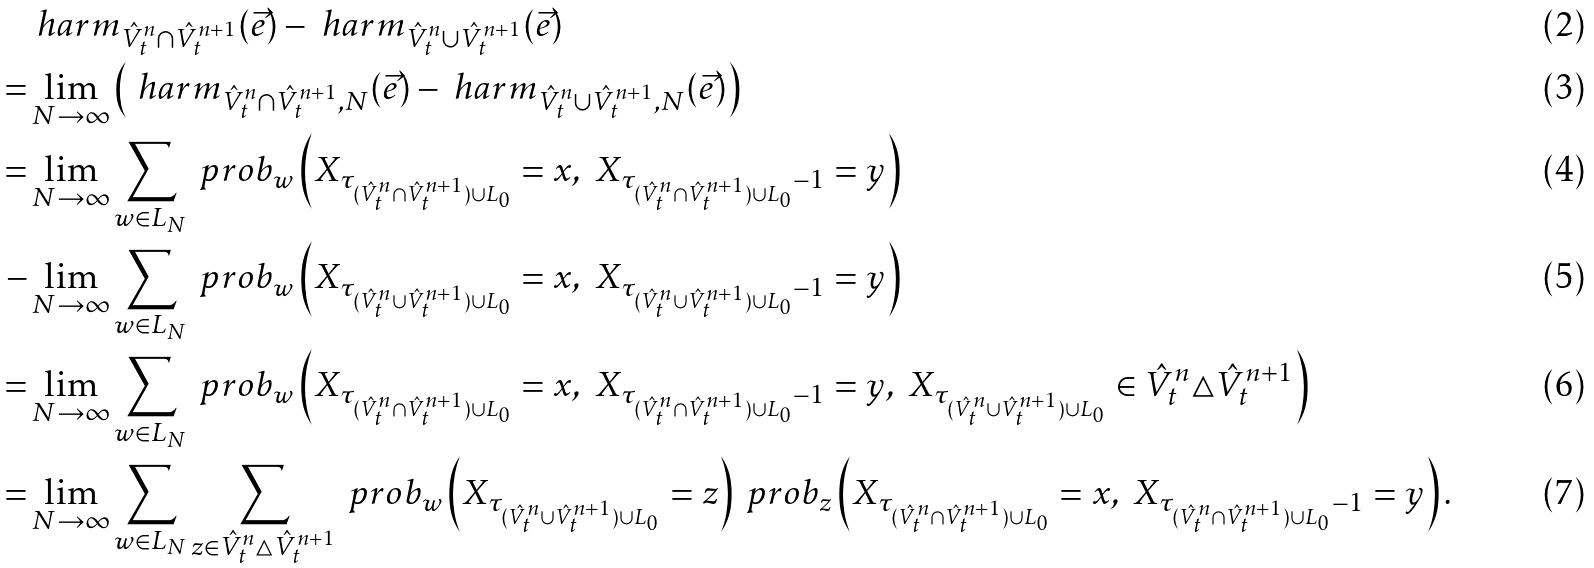<formula> <loc_0><loc_0><loc_500><loc_500>& \ h a r m _ { \hat { V } ^ { n } _ { t } \cap \hat { V } ^ { n + 1 } _ { t } } ( \vec { e } ) - \ h a r m _ { \hat { V } ^ { n } _ { t } \cup \hat { V } ^ { n + 1 } _ { t } } ( \vec { e } ) \\ = & \lim _ { N \to \infty } \left ( \ h a r m _ { \hat { V } ^ { n } _ { t } \cap \hat { V } ^ { n + 1 } _ { t } , N } ( \vec { e } ) - \ h a r m _ { \hat { V } ^ { n } _ { t } \cup \hat { V } ^ { n + 1 } _ { t } , N } ( \vec { e } ) \right ) \\ = & \lim _ { N \to \infty } \sum _ { w \in L _ { N } } \ p r o b _ { w } \left ( X _ { \tau _ { ( \hat { V } ^ { n } _ { t } \cap \hat { V } ^ { n + 1 } _ { t } ) \cup L _ { 0 } } } = x , \ X _ { \tau _ { ( \hat { V } ^ { n } _ { t } \cap \hat { V } ^ { n + 1 } _ { t } ) \cup L _ { 0 } } - 1 } = y \right ) \\ - & \lim _ { N \to \infty } \sum _ { w \in L _ { N } } \ p r o b _ { w } \left ( X _ { \tau _ { ( \hat { V } ^ { n } _ { t } \cup \hat { V } ^ { n + 1 } _ { t } ) \cup L _ { 0 } } } = x , \ X _ { \tau _ { ( \hat { V } ^ { n } _ { t } \cup \hat { V } ^ { n + 1 } _ { t } ) \cup L _ { 0 } } - 1 } = y \right ) \\ = & \lim _ { N \to \infty } \sum _ { w \in L _ { N } } \ p r o b _ { w } \left ( X _ { \tau _ { ( \hat { V } ^ { n } _ { t } \cap \hat { V } ^ { n + 1 } _ { t } ) \cup L _ { 0 } } } = x , \ X _ { \tau _ { ( \hat { V } ^ { n } _ { t } \cap \hat { V } ^ { n + 1 } _ { t } ) \cup L _ { 0 } } - 1 } = y , \ X _ { \tau _ { ( \hat { V } ^ { n } _ { t } \cup \hat { V } ^ { n + 1 } _ { t } ) \cup L _ { 0 } } } \in \hat { V } ^ { n } _ { t } \triangle \hat { V } ^ { n + 1 } _ { t } \right ) \\ = & \lim _ { N \to \infty } \sum _ { w \in L _ { N } } \sum _ { z \in \hat { V } ^ { n } _ { t } \triangle \hat { V } ^ { n + 1 } _ { t } } \ p r o b _ { w } \left ( X _ { \tau _ { ( \hat { V } ^ { n } _ { t } \cup \hat { V } ^ { n + 1 } _ { t } ) \cup L _ { 0 } } } = z \right ) \ p r o b _ { z } \left ( X _ { \tau _ { ( \hat { V } ^ { n } _ { t } \cap \hat { V } ^ { n + 1 } _ { t } ) \cup L _ { 0 } } } = x , \ X _ { \tau _ { ( \hat { V } ^ { n } _ { t } \cap \hat { V } ^ { n + 1 } _ { t } ) \cup L _ { 0 } } - 1 } = y \right ) .</formula> 